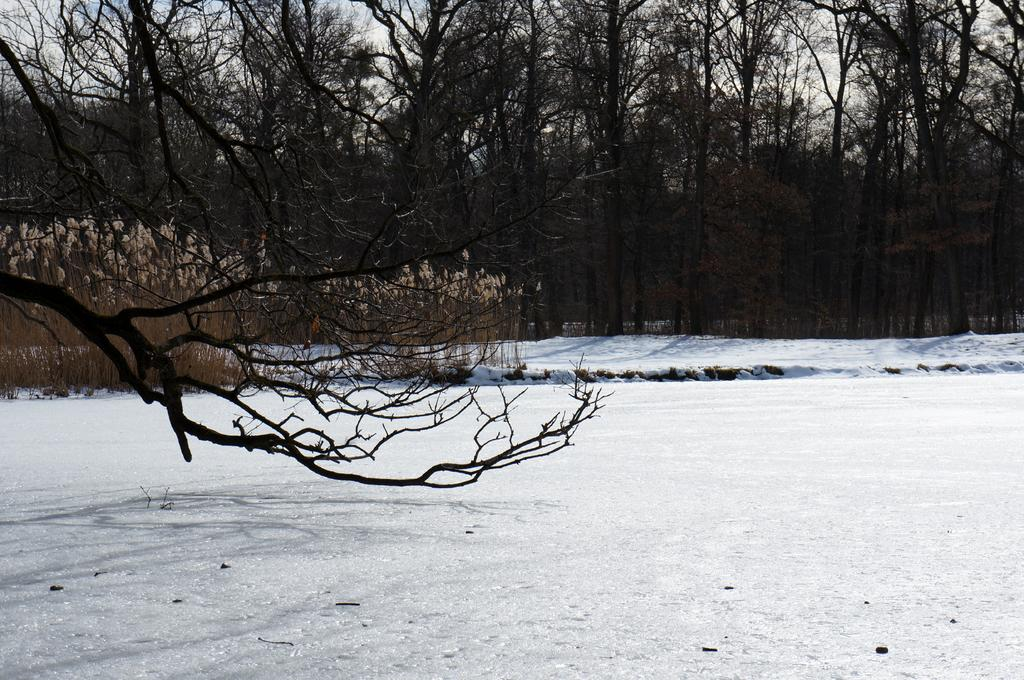What is the condition of the ground in the image? The ground is covered with snow in the image. What type of vegetation can be seen in the image? There are plants and trees in the image. What is visible in the sky in the image? The sky is visible in the image, and clouds are present. Where is the market located in the image? There is no market present in the image. What type of linen is draped over the trees in the image? There is no linen draped over the trees in the image; it only shows trees with snow on the ground. 